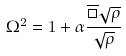Convert formula to latex. <formula><loc_0><loc_0><loc_500><loc_500>\Omega ^ { 2 } = 1 + \alpha \frac { \overline { \Box } \sqrt { \rho } } { \sqrt { \rho } }</formula> 